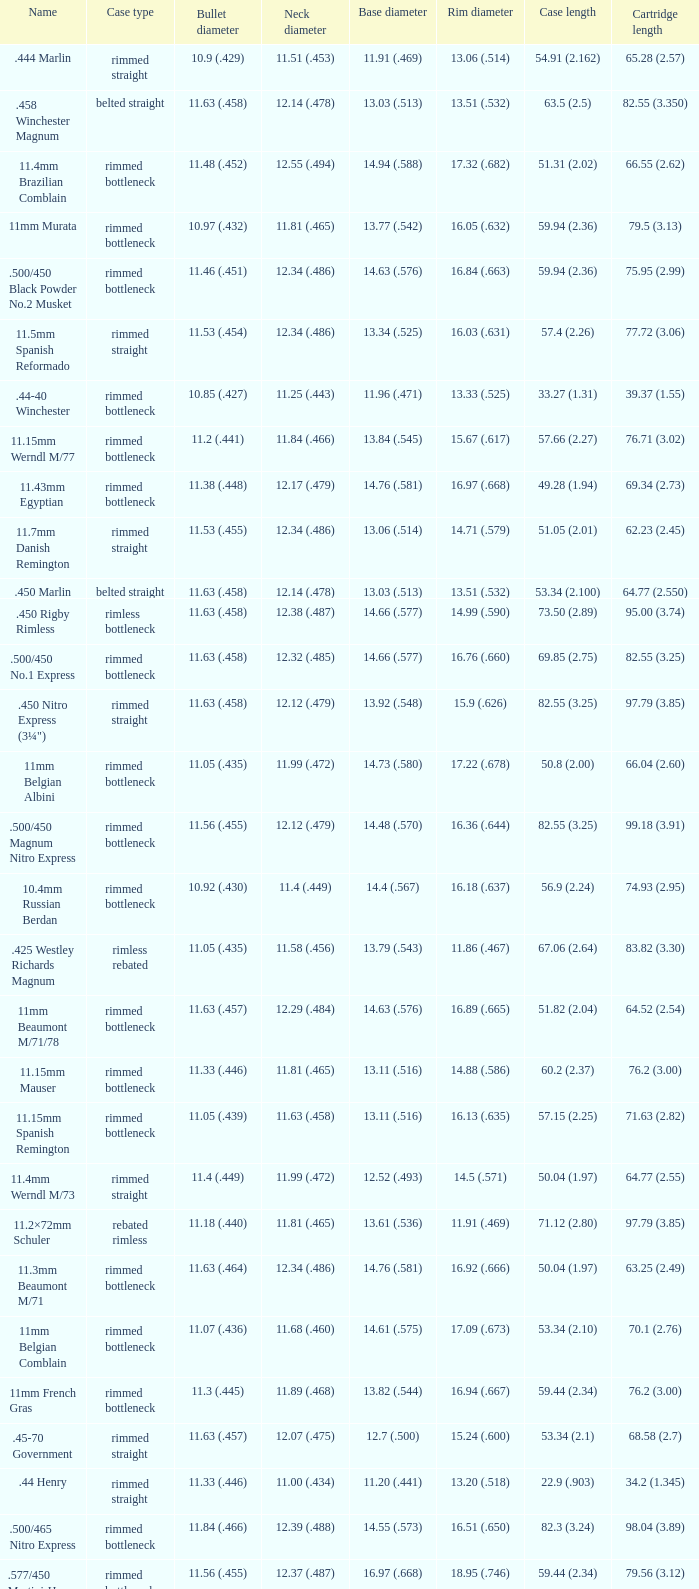Which Rim diameter has a Neck diameter of 11.84 (.466)? 15.67 (.617). 